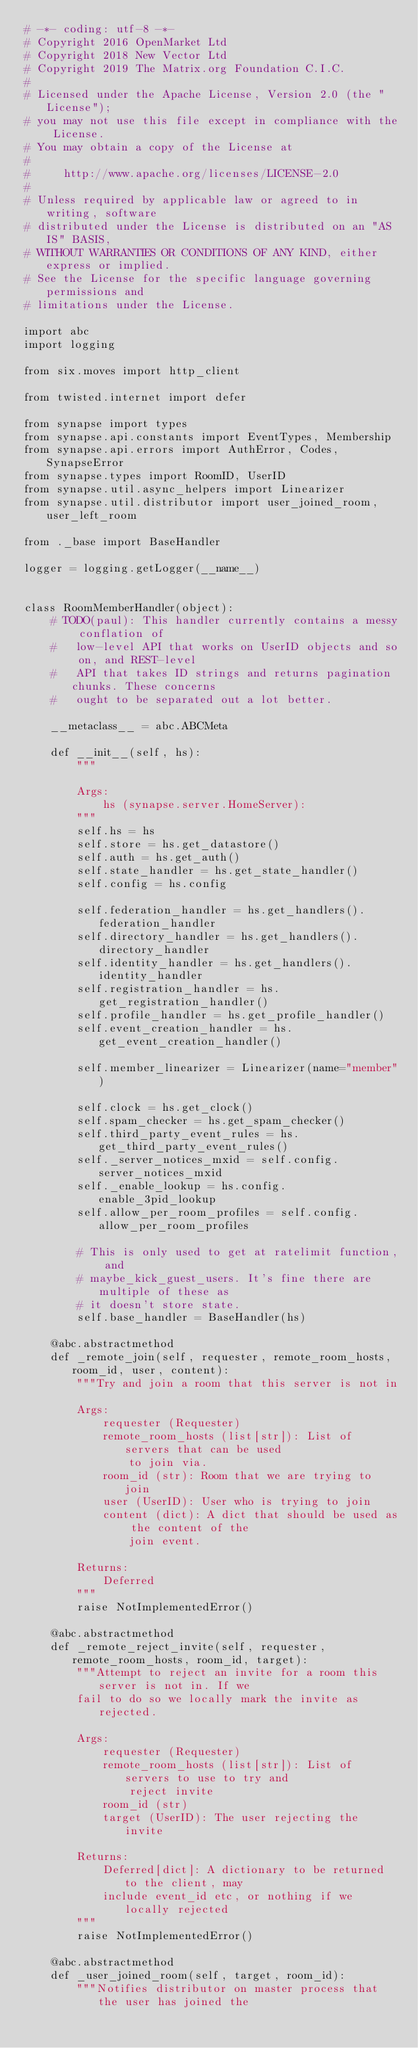<code> <loc_0><loc_0><loc_500><loc_500><_Python_># -*- coding: utf-8 -*-
# Copyright 2016 OpenMarket Ltd
# Copyright 2018 New Vector Ltd
# Copyright 2019 The Matrix.org Foundation C.I.C.
#
# Licensed under the Apache License, Version 2.0 (the "License");
# you may not use this file except in compliance with the License.
# You may obtain a copy of the License at
#
#     http://www.apache.org/licenses/LICENSE-2.0
#
# Unless required by applicable law or agreed to in writing, software
# distributed under the License is distributed on an "AS IS" BASIS,
# WITHOUT WARRANTIES OR CONDITIONS OF ANY KIND, either express or implied.
# See the License for the specific language governing permissions and
# limitations under the License.

import abc
import logging

from six.moves import http_client

from twisted.internet import defer

from synapse import types
from synapse.api.constants import EventTypes, Membership
from synapse.api.errors import AuthError, Codes, SynapseError
from synapse.types import RoomID, UserID
from synapse.util.async_helpers import Linearizer
from synapse.util.distributor import user_joined_room, user_left_room

from ._base import BaseHandler

logger = logging.getLogger(__name__)


class RoomMemberHandler(object):
    # TODO(paul): This handler currently contains a messy conflation of
    #   low-level API that works on UserID objects and so on, and REST-level
    #   API that takes ID strings and returns pagination chunks. These concerns
    #   ought to be separated out a lot better.

    __metaclass__ = abc.ABCMeta

    def __init__(self, hs):
        """

        Args:
            hs (synapse.server.HomeServer):
        """
        self.hs = hs
        self.store = hs.get_datastore()
        self.auth = hs.get_auth()
        self.state_handler = hs.get_state_handler()
        self.config = hs.config

        self.federation_handler = hs.get_handlers().federation_handler
        self.directory_handler = hs.get_handlers().directory_handler
        self.identity_handler = hs.get_handlers().identity_handler
        self.registration_handler = hs.get_registration_handler()
        self.profile_handler = hs.get_profile_handler()
        self.event_creation_handler = hs.get_event_creation_handler()

        self.member_linearizer = Linearizer(name="member")

        self.clock = hs.get_clock()
        self.spam_checker = hs.get_spam_checker()
        self.third_party_event_rules = hs.get_third_party_event_rules()
        self._server_notices_mxid = self.config.server_notices_mxid
        self._enable_lookup = hs.config.enable_3pid_lookup
        self.allow_per_room_profiles = self.config.allow_per_room_profiles

        # This is only used to get at ratelimit function, and
        # maybe_kick_guest_users. It's fine there are multiple of these as
        # it doesn't store state.
        self.base_handler = BaseHandler(hs)

    @abc.abstractmethod
    def _remote_join(self, requester, remote_room_hosts, room_id, user, content):
        """Try and join a room that this server is not in

        Args:
            requester (Requester)
            remote_room_hosts (list[str]): List of servers that can be used
                to join via.
            room_id (str): Room that we are trying to join
            user (UserID): User who is trying to join
            content (dict): A dict that should be used as the content of the
                join event.

        Returns:
            Deferred
        """
        raise NotImplementedError()

    @abc.abstractmethod
    def _remote_reject_invite(self, requester, remote_room_hosts, room_id, target):
        """Attempt to reject an invite for a room this server is not in. If we
        fail to do so we locally mark the invite as rejected.

        Args:
            requester (Requester)
            remote_room_hosts (list[str]): List of servers to use to try and
                reject invite
            room_id (str)
            target (UserID): The user rejecting the invite

        Returns:
            Deferred[dict]: A dictionary to be returned to the client, may
            include event_id etc, or nothing if we locally rejected
        """
        raise NotImplementedError()

    @abc.abstractmethod
    def _user_joined_room(self, target, room_id):
        """Notifies distributor on master process that the user has joined the</code> 